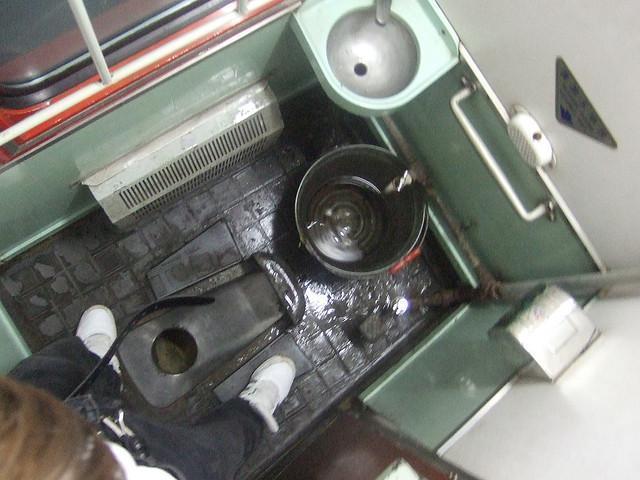How many people are there?
Give a very brief answer. 1. How many orange and white cats are in the image?
Give a very brief answer. 0. 